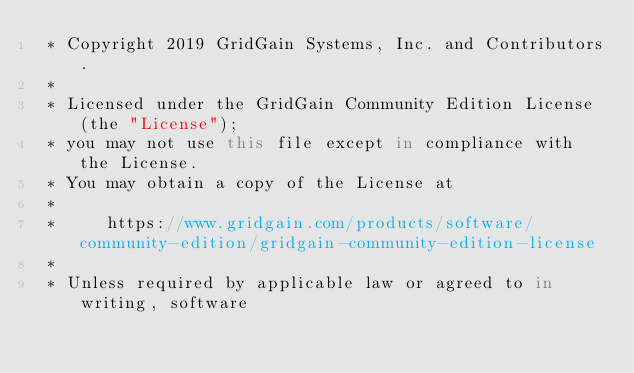<code> <loc_0><loc_0><loc_500><loc_500><_C#_> * Copyright 2019 GridGain Systems, Inc. and Contributors.
 *
 * Licensed under the GridGain Community Edition License (the "License");
 * you may not use this file except in compliance with the License.
 * You may obtain a copy of the License at
 *
 *     https://www.gridgain.com/products/software/community-edition/gridgain-community-edition-license
 *
 * Unless required by applicable law or agreed to in writing, software</code> 